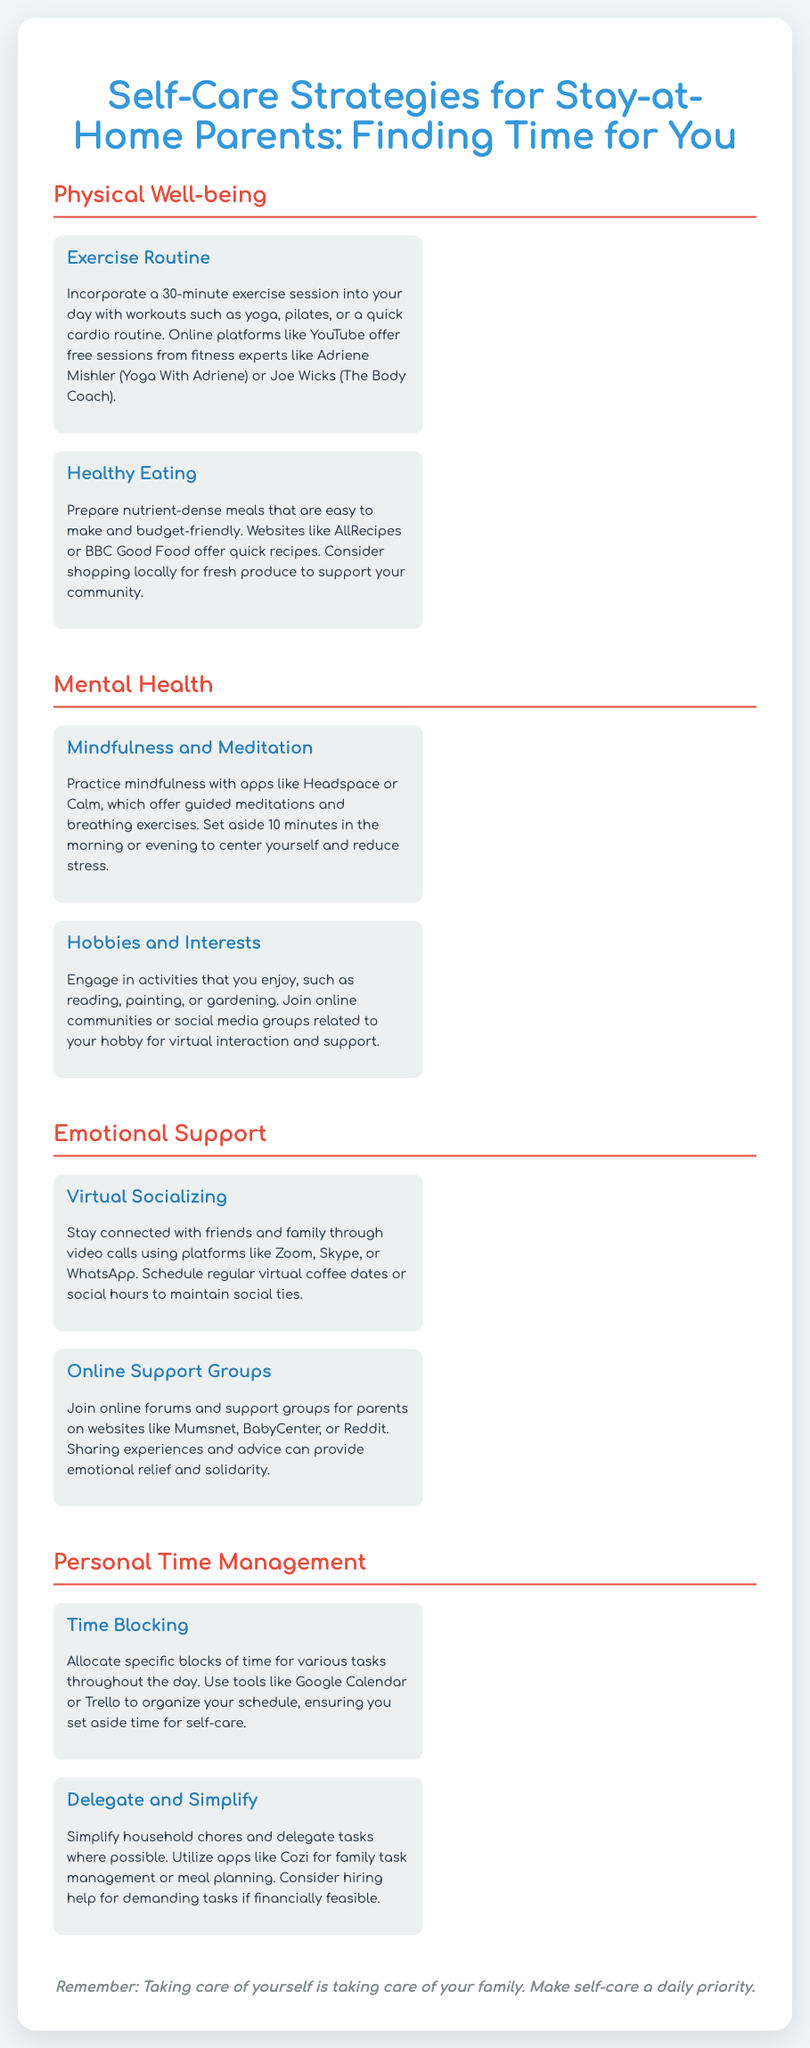What are two types of exercise mentioned? The poster highlights yoga and pilates as examples of exercise routines for self-care.
Answer: yoga, pilates What app is recommended for mindfulness practice? The poster suggests using the app Headspace for practicing mindfulness and meditation.
Answer: Headspace How many minutes should you allocate for exercise? The suggested duration for exercise in the poster is 30 minutes.
Answer: 30 minutes What type of meals does the poster suggest preparing? The poster recommends preparing nutrient-dense meals that are easy to make and budget-friendly.
Answer: nutrient-dense meals What platforms can be used for virtual socializing? The document mentions using Zoom, Skype, or WhatsApp for staying connected with friends and family.
Answer: Zoom, Skype, WhatsApp Name one tool for time management mentioned in the poster. The poster lists Google Calendar as a tool for organizing schedules and managing time.
Answer: Google Calendar What is a suggested online community activity? The poster encourages joining online communities or social media groups related to your hobby for interaction and support.
Answer: join online communities What is one strategy to simplify household chores? The document suggests utilizing apps like Cozi for family task management as a way to simplify chores.
Answer: Cozi 